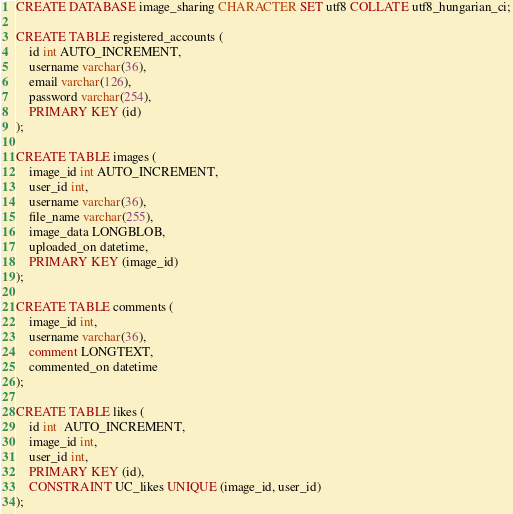Convert code to text. <code><loc_0><loc_0><loc_500><loc_500><_SQL_>CREATE DATABASE image_sharing CHARACTER SET utf8 COLLATE utf8_hungarian_ci;

CREATE TABLE registered_accounts (
    id int AUTO_INCREMENT,
    username varchar(36),
    email varchar(126),
    password varchar(254),
    PRIMARY KEY (id)
);

CREATE TABLE images (
    image_id int AUTO_INCREMENT,
    user_id int,
    username varchar(36),
    file_name varchar(255),
    image_data LONGBLOB,
    uploaded_on datetime,
    PRIMARY KEY (image_id)
);

CREATE TABLE comments (
    image_id int,
    username varchar(36),
    comment LONGTEXT,
    commented_on datetime
);

CREATE TABLE likes (
    id int  AUTO_INCREMENT,
    image_id int,
    user_id int,
    PRIMARY KEY (id),
    CONSTRAINT UC_likes UNIQUE (image_id, user_id)
);</code> 